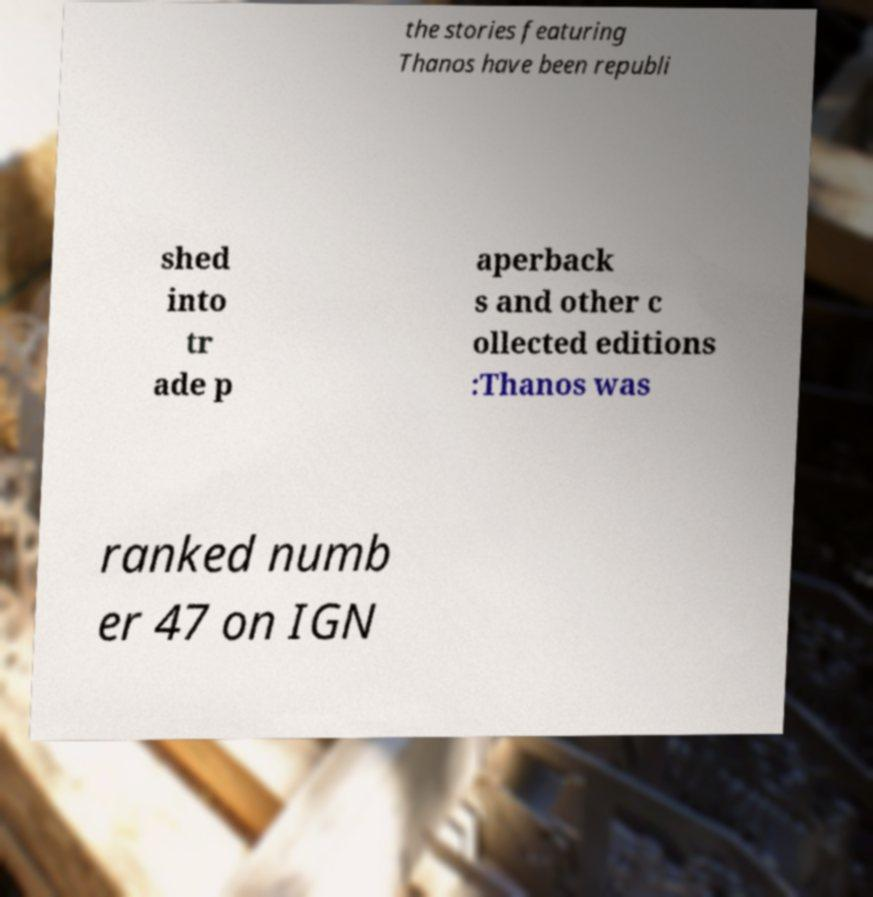I need the written content from this picture converted into text. Can you do that? the stories featuring Thanos have been republi shed into tr ade p aperback s and other c ollected editions :Thanos was ranked numb er 47 on IGN 